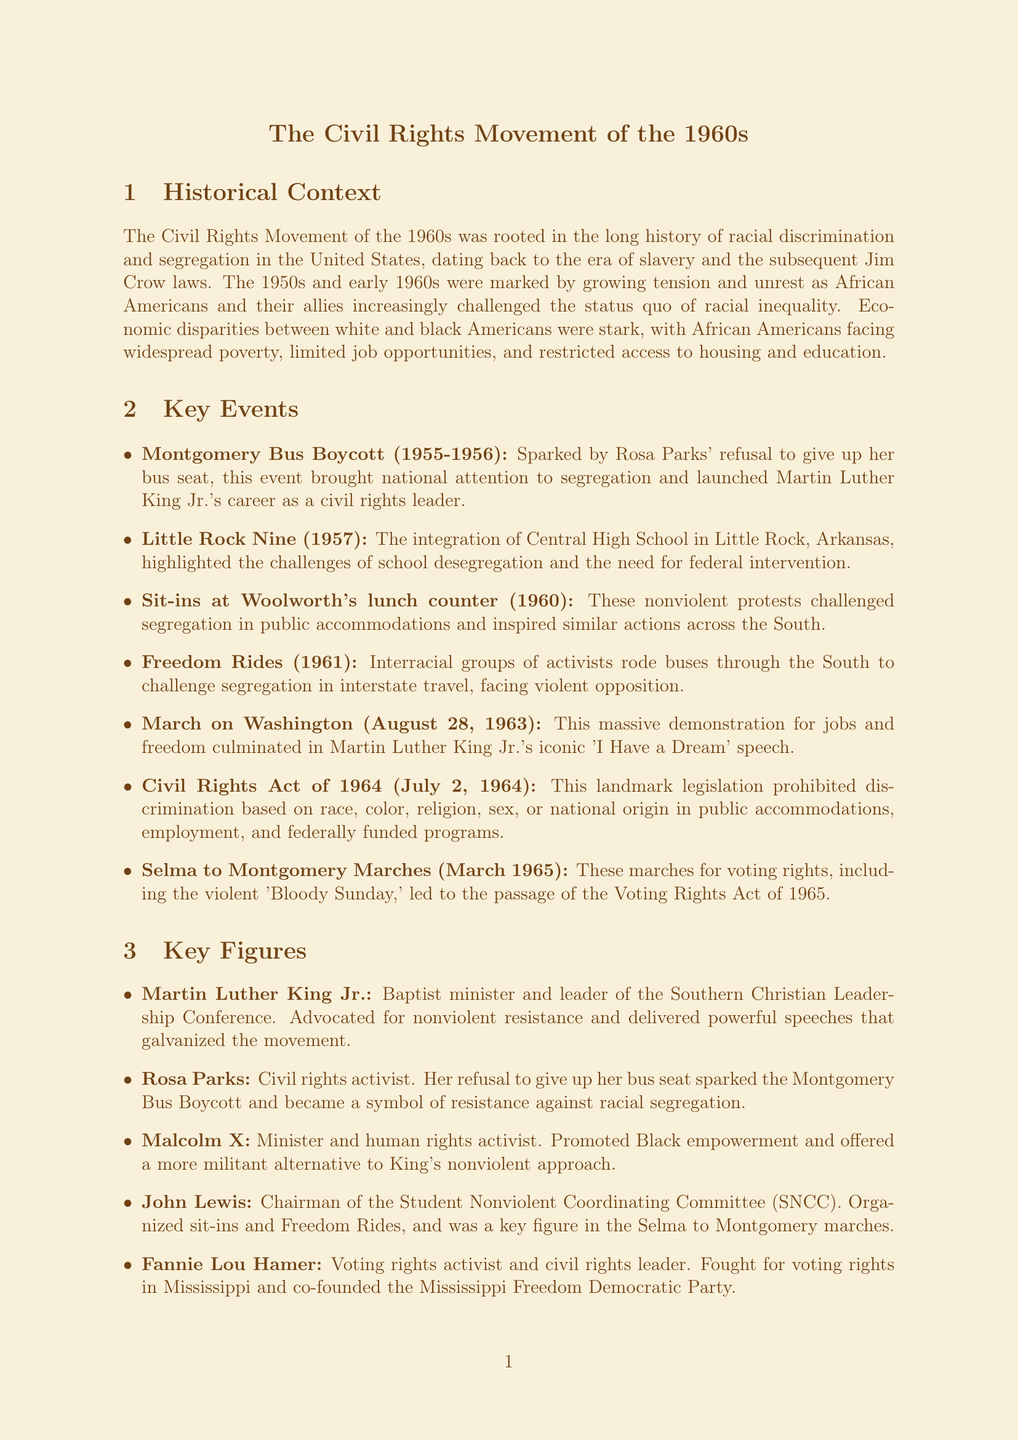What sparked the Montgomery Bus Boycott? The Montgomery Bus Boycott was sparked by Rosa Parks' refusal to give up her bus seat.
Answer: Rosa Parks' refusal What year did the March on Washington occur? The March on Washington took place on August 28, 1963.
Answer: August 28, 1963 Who was the chairman of the Student Nonviolent Coordinating Committee (SNCC)? The chairman of the SNCC was John Lewis.
Answer: John Lewis Which legislation prohibited discrimination based on race and other factors? The landmark legislation that prohibited discrimination is the Civil Rights Act of 1964.
Answer: Civil Rights Act of 1964 What was the significance of the Selma to Montgomery Marches? The Selma to Montgomery Marches were significant for leading to the passage of the Voting Rights Act of 1965.
Answer: Voting Rights Act of 1965 What type of protest did the sit-ins at Woolworth's lunch counter represent? The sit-ins at Woolworth's lunch counter represented nonviolent protests against segregation.
Answer: Nonviolent protests What was one societal impact of the Civil Rights Movement in the legal and political area? One societal impact was the increased political representation for African Americans.
Answer: Increased political representation Which key figure promoted Black empowerment and a more militant approach? The key figure who promoted Black empowerment was Malcolm X.
Answer: Malcolm X What area did the Civil Rights Movement improve access to for African Americans? The Civil Rights Movement improved access to education for African Americans.
Answer: Education 